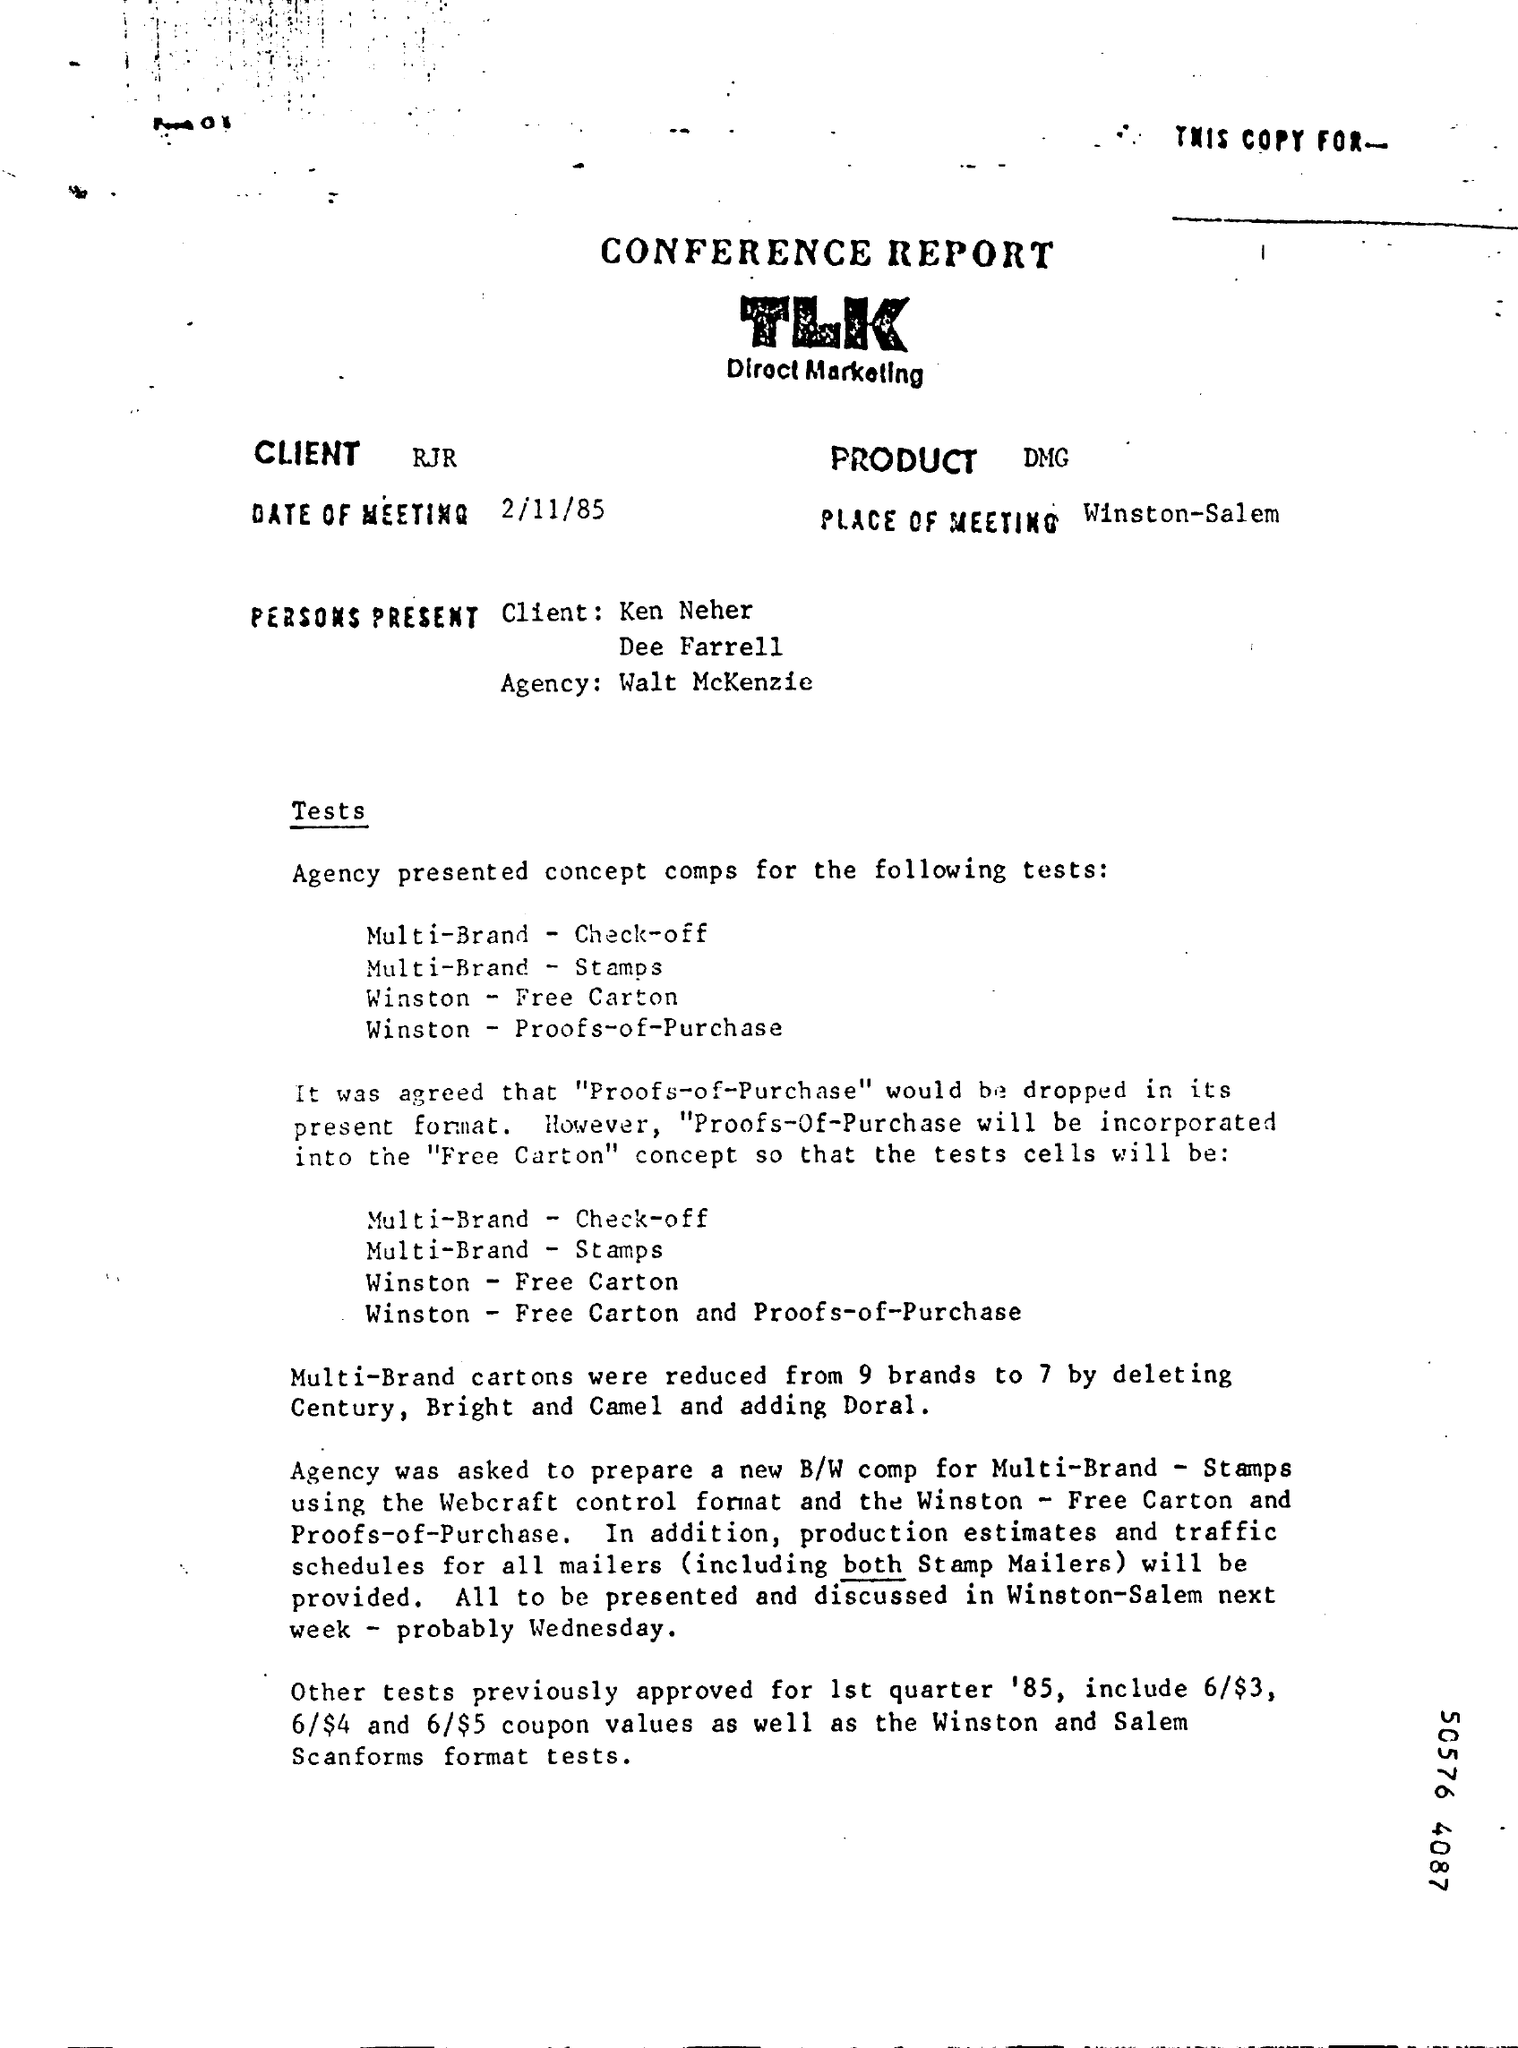When was the meeting held ?
Provide a short and direct response. 2/11/85. What is the place of meeting ?
Your answer should be compact. Winston-Salem. As per the meeting, "Proofs-of-Purchase" will be incorporated into which concept ?
Your response must be concise. Free carton concept. Multi-Brand cartons were reduced from 9 brands to how many ?
Your response must be concise. 7. 